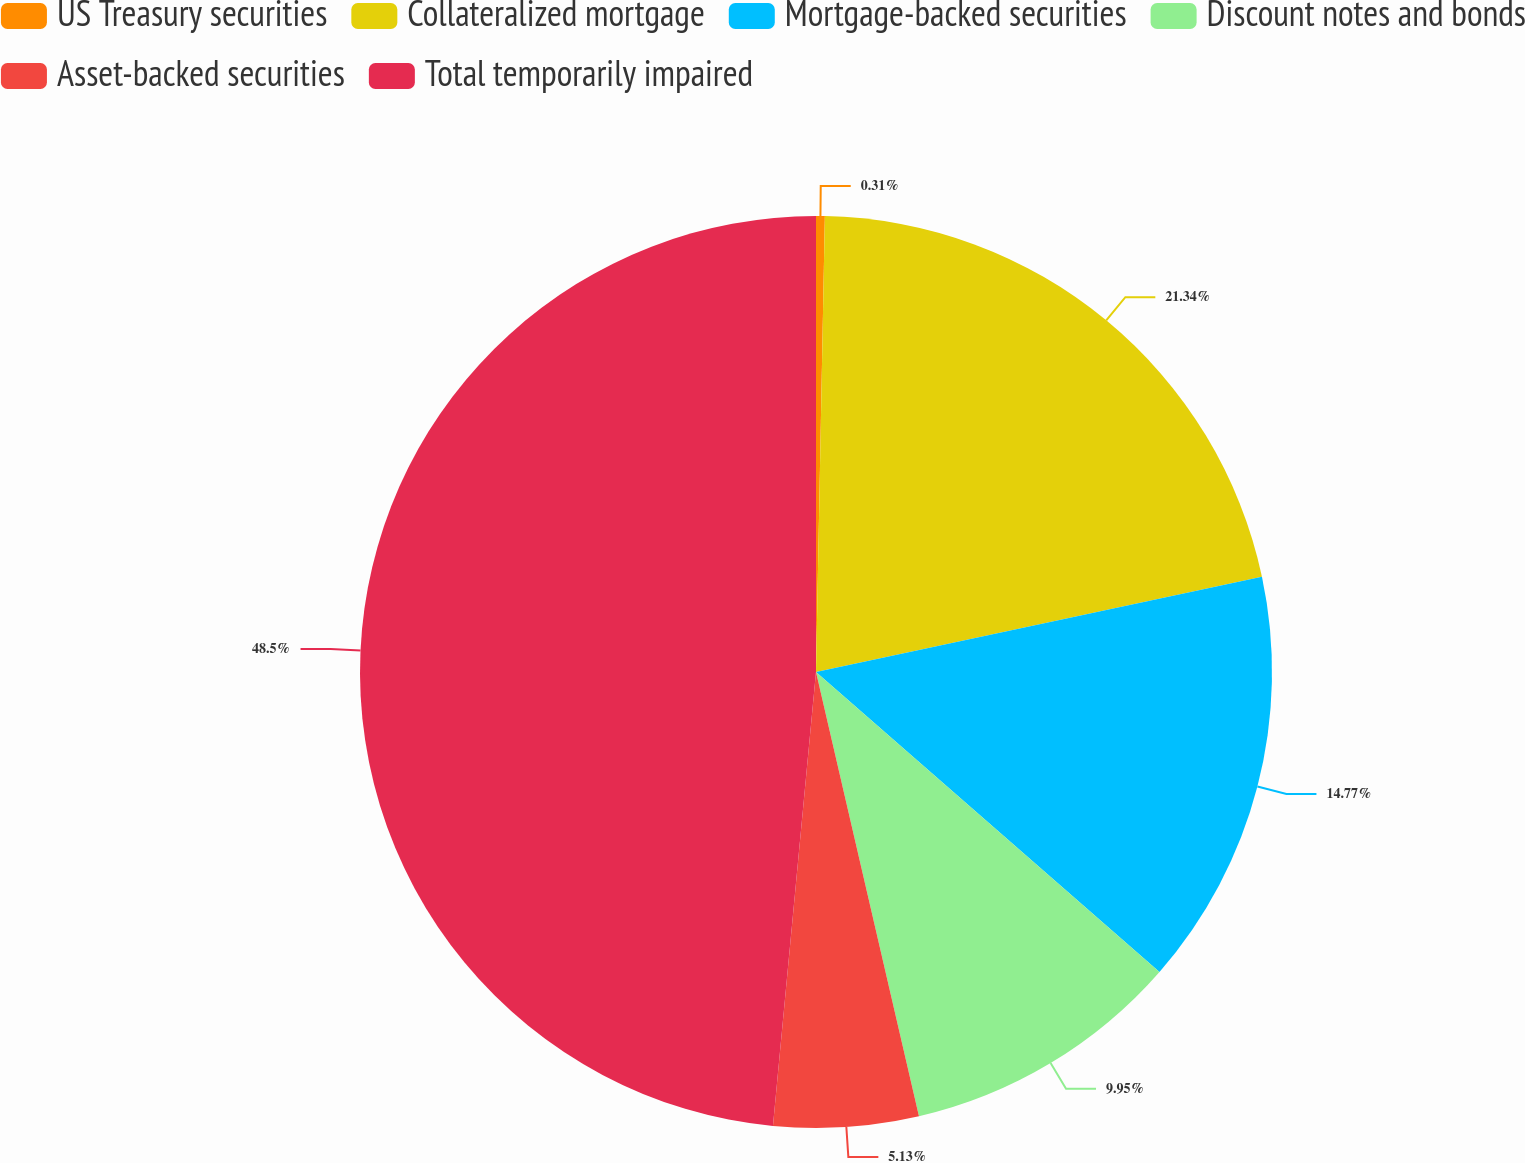<chart> <loc_0><loc_0><loc_500><loc_500><pie_chart><fcel>US Treasury securities<fcel>Collateralized mortgage<fcel>Mortgage-backed securities<fcel>Discount notes and bonds<fcel>Asset-backed securities<fcel>Total temporarily impaired<nl><fcel>0.31%<fcel>21.34%<fcel>14.77%<fcel>9.95%<fcel>5.13%<fcel>48.49%<nl></chart> 